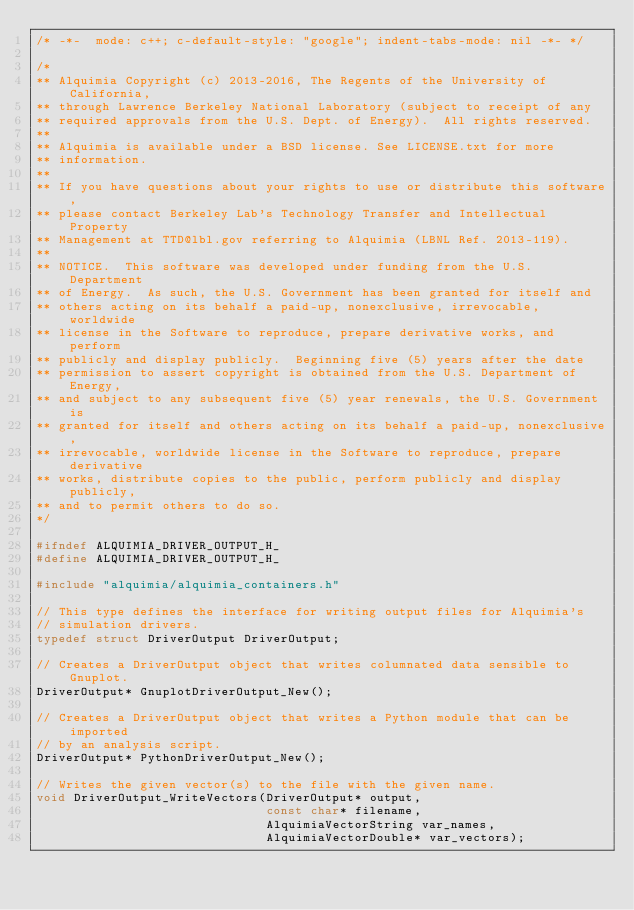Convert code to text. <code><loc_0><loc_0><loc_500><loc_500><_C_>/* -*-  mode: c++; c-default-style: "google"; indent-tabs-mode: nil -*- */

/*
** Alquimia Copyright (c) 2013-2016, The Regents of the University of California, 
** through Lawrence Berkeley National Laboratory (subject to receipt of any 
** required approvals from the U.S. Dept. of Energy).  All rights reserved.
** 
** Alquimia is available under a BSD license. See LICENSE.txt for more
** information.
**
** If you have questions about your rights to use or distribute this software, 
** please contact Berkeley Lab's Technology Transfer and Intellectual Property 
** Management at TTD@lbl.gov referring to Alquimia (LBNL Ref. 2013-119).
** 
** NOTICE.  This software was developed under funding from the U.S. Department 
** of Energy.  As such, the U.S. Government has been granted for itself and 
** others acting on its behalf a paid-up, nonexclusive, irrevocable, worldwide 
** license in the Software to reproduce, prepare derivative works, and perform 
** publicly and display publicly.  Beginning five (5) years after the date 
** permission to assert copyright is obtained from the U.S. Department of Energy, 
** and subject to any subsequent five (5) year renewals, the U.S. Government is 
** granted for itself and others acting on its behalf a paid-up, nonexclusive, 
** irrevocable, worldwide license in the Software to reproduce, prepare derivative
** works, distribute copies to the public, perform publicly and display publicly, 
** and to permit others to do so.
*/

#ifndef ALQUIMIA_DRIVER_OUTPUT_H_
#define ALQUIMIA_DRIVER_OUTPUT_H_

#include "alquimia/alquimia_containers.h"

// This type defines the interface for writing output files for Alquimia's 
// simulation drivers.
typedef struct DriverOutput DriverOutput;

// Creates a DriverOutput object that writes columnated data sensible to Gnuplot.
DriverOutput* GnuplotDriverOutput_New();

// Creates a DriverOutput object that writes a Python module that can be imported
// by an analysis script.
DriverOutput* PythonDriverOutput_New();

// Writes the given vector(s) to the file with the given name.
void DriverOutput_WriteVectors(DriverOutput* output, 
                               const char* filename,
                               AlquimiaVectorString var_names,
                               AlquimiaVectorDouble* var_vectors);
</code> 